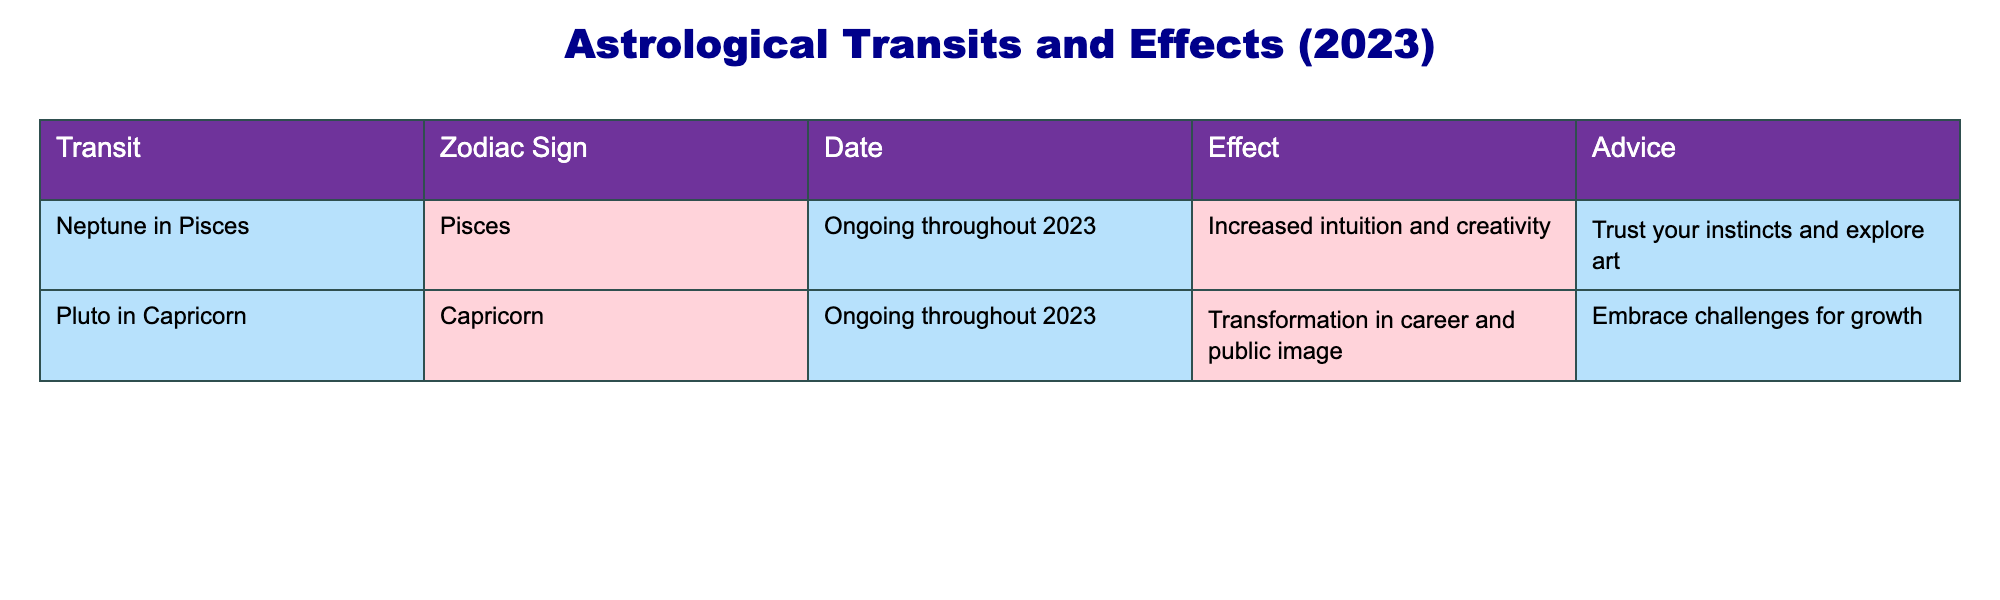What is the effect of Neptune's transit in Pisces? The table states that the effect of Neptune in Pisces is "Increased intuition and creativity." This information is directly listed in the table under the "Effect" column for this specific transit.
Answer: Increased intuition and creativity Which zodiac sign is experiencing Pluto's ongoing transit? According to the table, Pluto is in Capricorn, which is indicated in the row where Pluto's transit is listed. Thus, the zodiac sign experiencing this transit is Capricorn.
Answer: Capricorn What advice is given for those under the influence of Neptune in Pisces? The table provides advice associated with Neptune's transit in Pisces, which is "Trust your instincts and explore art." This is a direct reference from the advice column for this transit.
Answer: Trust your instincts and explore art Is there any zodiac sign affected by both transits mentioned in the table? The table lists only two transits: Neptune in Pisces and Pluto in Capricorn. Since Pisces and Capricorn are different signs, there is no overlap or zodiac sign affected by both transits listed.
Answer: No What is the main difference between the effects of Neptune in Pisces and Pluto in Capricorn? The effect of Neptune in Pisces focuses on "Increased intuition and creativity," while Pluto in Capricorn emphasizes "Transformation in career and public image." Therefore, the main difference lies in the areas of life these transits influence; one is more personal and creative, while the other is professional and societal.
Answer: Intuition and creativity vs. transformation in career and public image What is the common theme in the advice provided for both transits? The advice given for Neptune in Pisces is about trusting instincts and exploring creativity, while Pluto in Capricorn encourages embracing challenges for growth. The common theme between both pieces of advice is personal development, whether through intuition and creativity or through overcoming challenges in one's career path.
Answer: Personal development How many total transits are discussed in the table? The table includes two distinct transits: Neptune in Pisces and Pluto in Capricorn. Adding these transits gives a total of two.
Answer: 2 What is the primary focus of Pluto's influence according to the table? Pluto's influence, as stated in the effect column, is focused on "Transformation in career and public image." This gives insight into where individuals might feel Pluto's impact the most during its transit in Capricorn.
Answer: Transformation in career and public image 